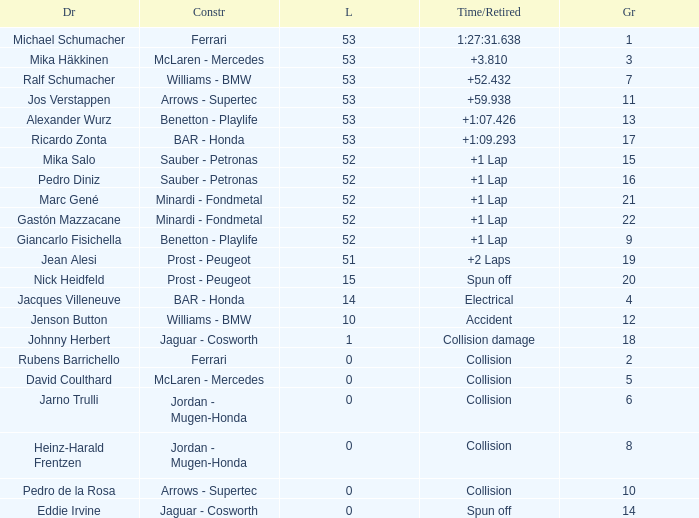Parse the table in full. {'header': ['Dr', 'Constr', 'L', 'Time/Retired', 'Gr'], 'rows': [['Michael Schumacher', 'Ferrari', '53', '1:27:31.638', '1'], ['Mika Häkkinen', 'McLaren - Mercedes', '53', '+3.810', '3'], ['Ralf Schumacher', 'Williams - BMW', '53', '+52.432', '7'], ['Jos Verstappen', 'Arrows - Supertec', '53', '+59.938', '11'], ['Alexander Wurz', 'Benetton - Playlife', '53', '+1:07.426', '13'], ['Ricardo Zonta', 'BAR - Honda', '53', '+1:09.293', '17'], ['Mika Salo', 'Sauber - Petronas', '52', '+1 Lap', '15'], ['Pedro Diniz', 'Sauber - Petronas', '52', '+1 Lap', '16'], ['Marc Gené', 'Minardi - Fondmetal', '52', '+1 Lap', '21'], ['Gastón Mazzacane', 'Minardi - Fondmetal', '52', '+1 Lap', '22'], ['Giancarlo Fisichella', 'Benetton - Playlife', '52', '+1 Lap', '9'], ['Jean Alesi', 'Prost - Peugeot', '51', '+2 Laps', '19'], ['Nick Heidfeld', 'Prost - Peugeot', '15', 'Spun off', '20'], ['Jacques Villeneuve', 'BAR - Honda', '14', 'Electrical', '4'], ['Jenson Button', 'Williams - BMW', '10', 'Accident', '12'], ['Johnny Herbert', 'Jaguar - Cosworth', '1', 'Collision damage', '18'], ['Rubens Barrichello', 'Ferrari', '0', 'Collision', '2'], ['David Coulthard', 'McLaren - Mercedes', '0', 'Collision', '5'], ['Jarno Trulli', 'Jordan - Mugen-Honda', '0', 'Collision', '6'], ['Heinz-Harald Frentzen', 'Jordan - Mugen-Honda', '0', 'Collision', '8'], ['Pedro de la Rosa', 'Arrows - Supertec', '0', 'Collision', '10'], ['Eddie Irvine', 'Jaguar - Cosworth', '0', 'Spun off', '14']]} What is the average Laps for a grid smaller than 17, and a Constructor of williams - bmw, driven by jenson button? 10.0. 